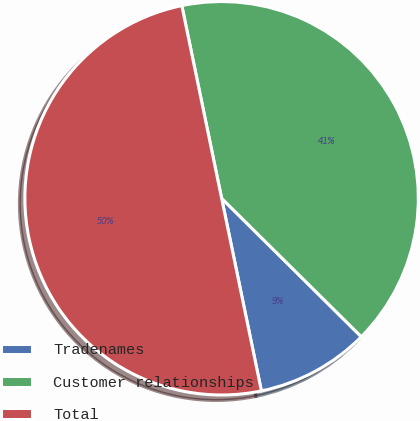Convert chart. <chart><loc_0><loc_0><loc_500><loc_500><pie_chart><fcel>Tradenames<fcel>Customer relationships<fcel>Total<nl><fcel>9.33%<fcel>40.67%<fcel>50.0%<nl></chart> 